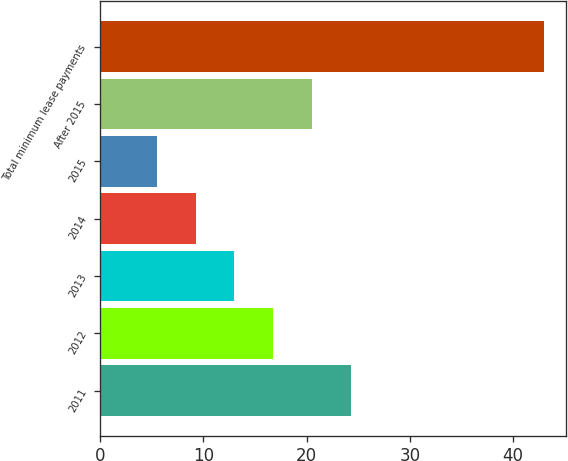Convert chart. <chart><loc_0><loc_0><loc_500><loc_500><bar_chart><fcel>2011<fcel>2012<fcel>2013<fcel>2014<fcel>2015<fcel>After 2015<fcel>Total minimum lease payments<nl><fcel>24.25<fcel>16.75<fcel>13<fcel>9.25<fcel>5.5<fcel>20.5<fcel>43<nl></chart> 